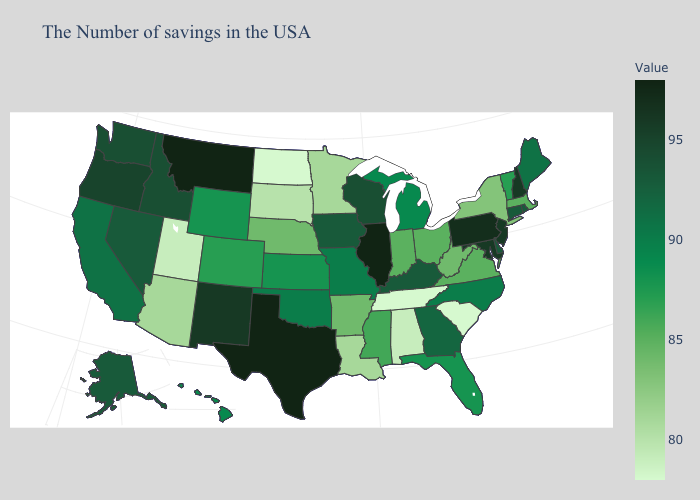Does Montana have the highest value in the West?
Short answer required. Yes. Does Louisiana have the highest value in the South?
Quick response, please. No. Does Kentucky have the highest value in the USA?
Keep it brief. No. Among the states that border Virginia , does North Carolina have the highest value?
Answer briefly. No. Among the states that border South Carolina , does Georgia have the lowest value?
Short answer required. No. Which states have the lowest value in the West?
Quick response, please. Utah. 